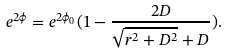<formula> <loc_0><loc_0><loc_500><loc_500>e ^ { 2 \phi } = e ^ { 2 \phi _ { 0 } } ( 1 - \frac { 2 D } { \sqrt { r ^ { 2 } + D ^ { 2 } } + D } ) .</formula> 